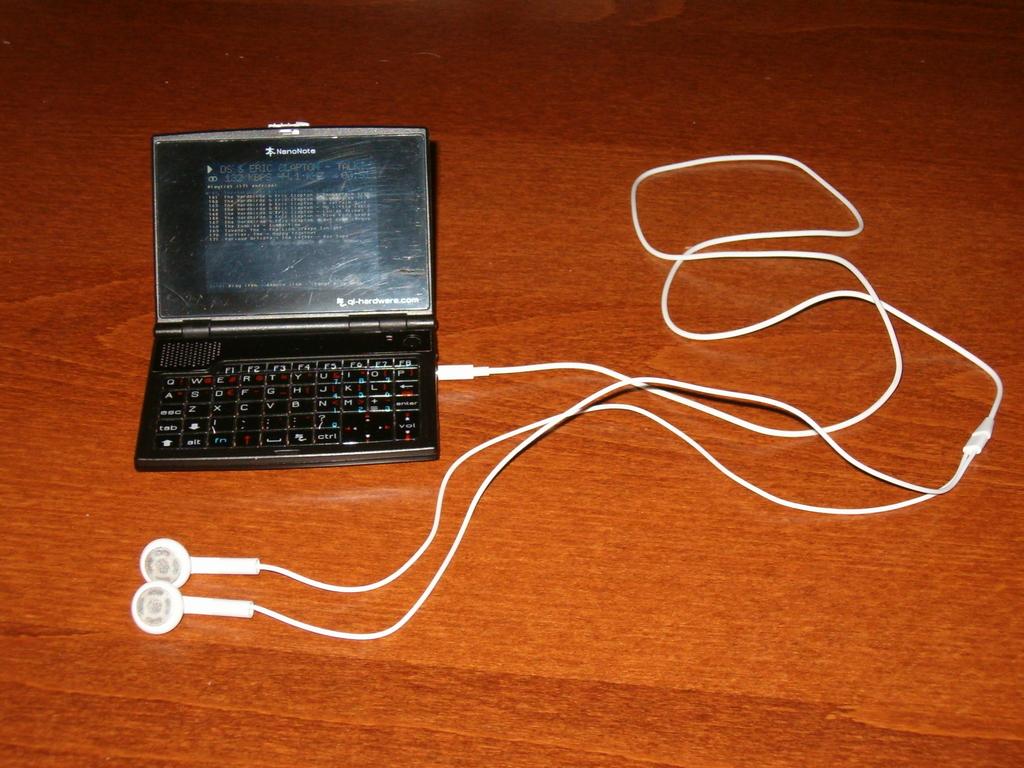What does it say on the top of the mini computer?
Offer a very short reply. Unanswerable. What is the brand of the computer?
Your answer should be compact. Nanonote. 